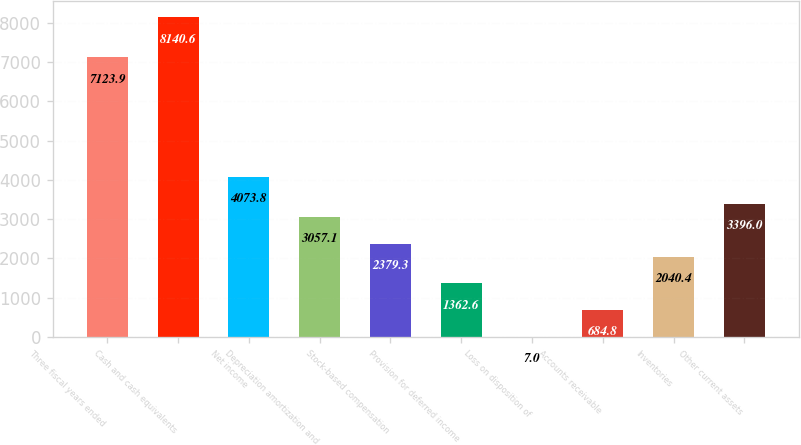Convert chart to OTSL. <chart><loc_0><loc_0><loc_500><loc_500><bar_chart><fcel>Three fiscal years ended<fcel>Cash and cash equivalents<fcel>Net income<fcel>Depreciation amortization and<fcel>Stock-based compensation<fcel>Provision for deferred income<fcel>Loss on disposition of<fcel>Accounts receivable<fcel>Inventories<fcel>Other current assets<nl><fcel>7123.9<fcel>8140.6<fcel>4073.8<fcel>3057.1<fcel>2379.3<fcel>1362.6<fcel>7<fcel>684.8<fcel>2040.4<fcel>3396<nl></chart> 